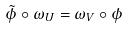Convert formula to latex. <formula><loc_0><loc_0><loc_500><loc_500>\tilde { \phi } \circ \omega _ { U } = \omega _ { V } \circ \phi</formula> 